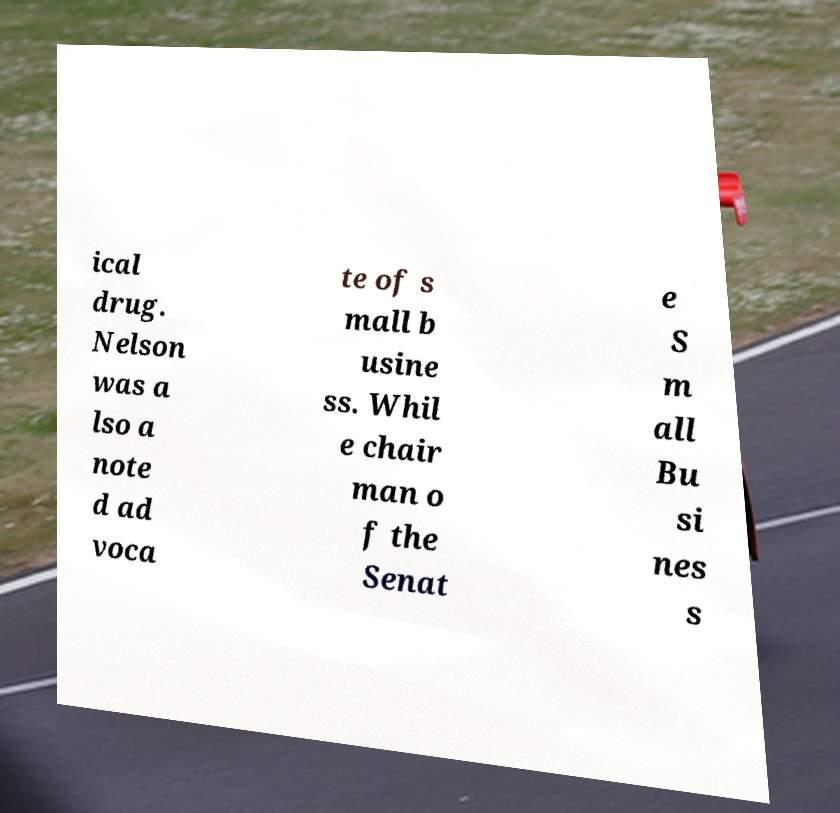Could you extract and type out the text from this image? ical drug. Nelson was a lso a note d ad voca te of s mall b usine ss. Whil e chair man o f the Senat e S m all Bu si nes s 